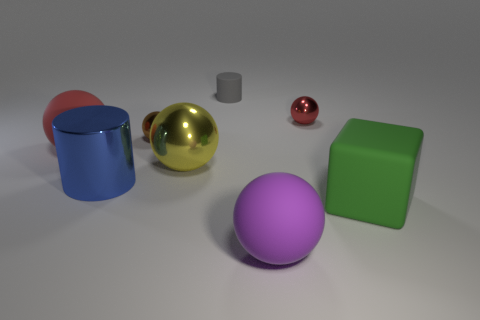Subtract 3 balls. How many balls are left? 2 Subtract all brown balls. How many balls are left? 4 Subtract all brown balls. How many balls are left? 4 Add 2 blue shiny things. How many objects exist? 10 Subtract all cyan balls. Subtract all yellow cylinders. How many balls are left? 5 Subtract all blocks. How many objects are left? 7 Add 5 red rubber objects. How many red rubber objects exist? 6 Subtract 0 purple blocks. How many objects are left? 8 Subtract all large red rubber things. Subtract all red matte balls. How many objects are left? 6 Add 4 shiny things. How many shiny things are left? 8 